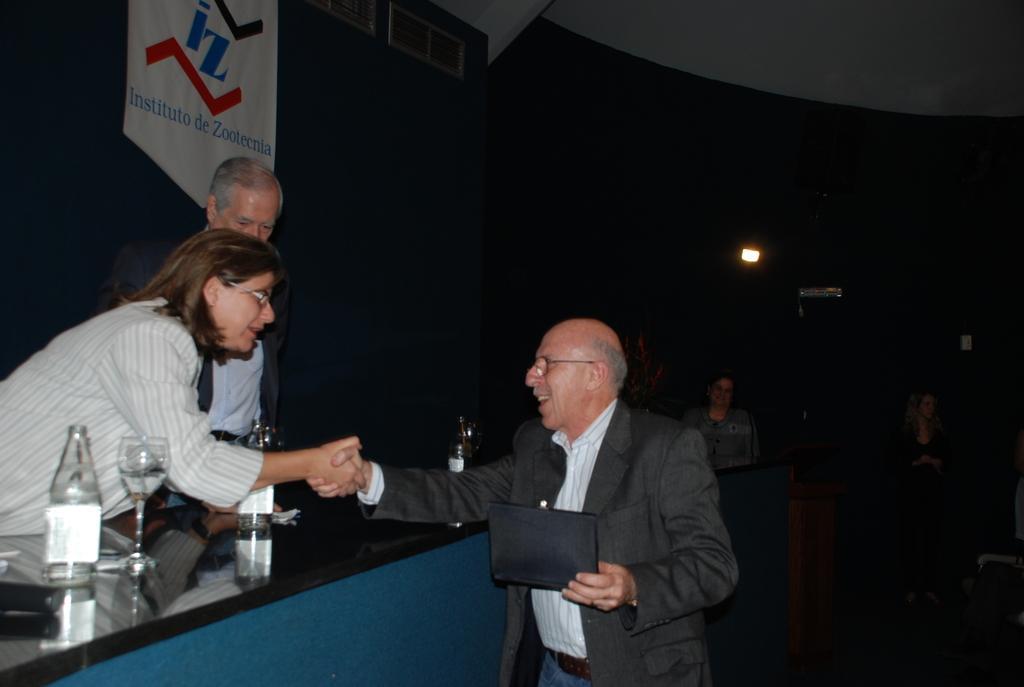Please provide a concise description of this image. In this image there are group of people, two people are standing and talking and holding their hands. At the back there is a podium. There are bottles and glasses on the table, at the back there is a banner, at the top there is a light. 